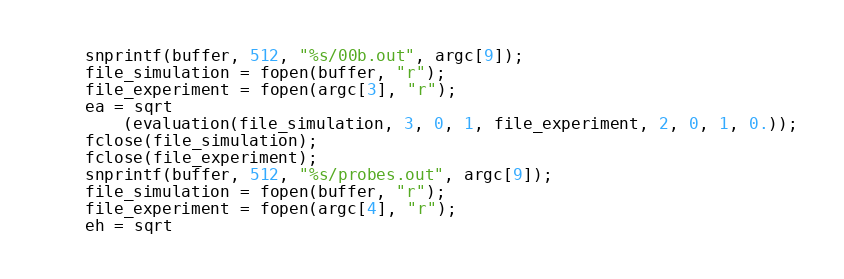<code> <loc_0><loc_0><loc_500><loc_500><_C_>	snprintf(buffer, 512, "%s/00b.out", argc[9]);
	file_simulation = fopen(buffer, "r");
	file_experiment = fopen(argc[3], "r");
	ea = sqrt
		(evaluation(file_simulation, 3, 0, 1, file_experiment, 2, 0, 1, 0.));
	fclose(file_simulation);
	fclose(file_experiment);
	snprintf(buffer, 512, "%s/probes.out", argc[9]);
	file_simulation = fopen(buffer, "r");
	file_experiment = fopen(argc[4], "r");
	eh = sqrt</code> 